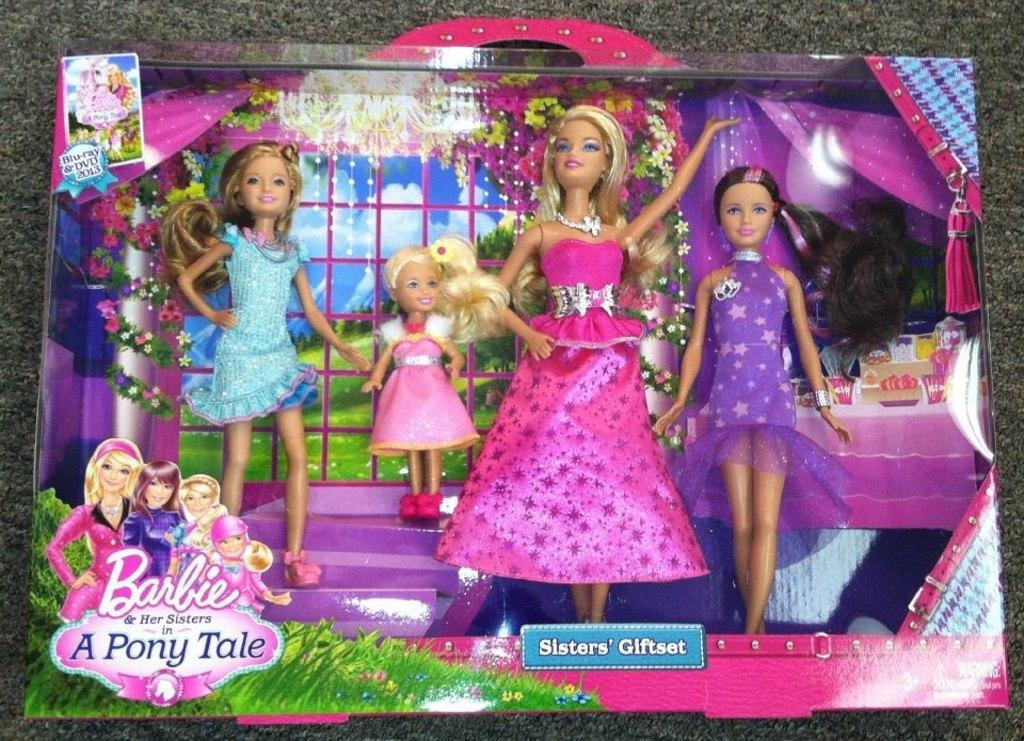Could you give a brief overview of what you see in this image? In this image there are Barbie dolls in a box. At the bottom of the image there is a mat on the surface. 